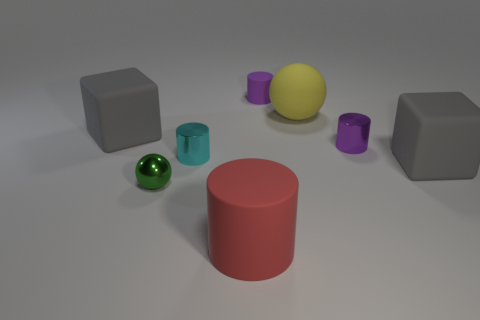What size is the red rubber object that is the same shape as the tiny cyan thing?
Your response must be concise. Large. Is there any other thing that has the same size as the red rubber cylinder?
Offer a very short reply. Yes. Does the big yellow matte object have the same shape as the red rubber object?
Make the answer very short. No. Are there fewer small cyan cylinders in front of the small green shiny ball than red objects that are to the right of the tiny cyan cylinder?
Make the answer very short. Yes. How many big gray rubber cubes are right of the big red matte cylinder?
Offer a very short reply. 1. Do the large matte object that is in front of the green thing and the matte thing that is on the left side of the large cylinder have the same shape?
Keep it short and to the point. No. What number of other things are there of the same color as the small matte thing?
Your response must be concise. 1. What is the material of the big gray block behind the gray rubber thing that is in front of the gray cube that is on the left side of the tiny cyan shiny cylinder?
Offer a very short reply. Rubber. What is the material of the small thing that is in front of the gray rubber block right of the large yellow rubber thing?
Offer a very short reply. Metal. Are there fewer rubber objects that are behind the large red object than rubber things?
Provide a short and direct response. Yes. 